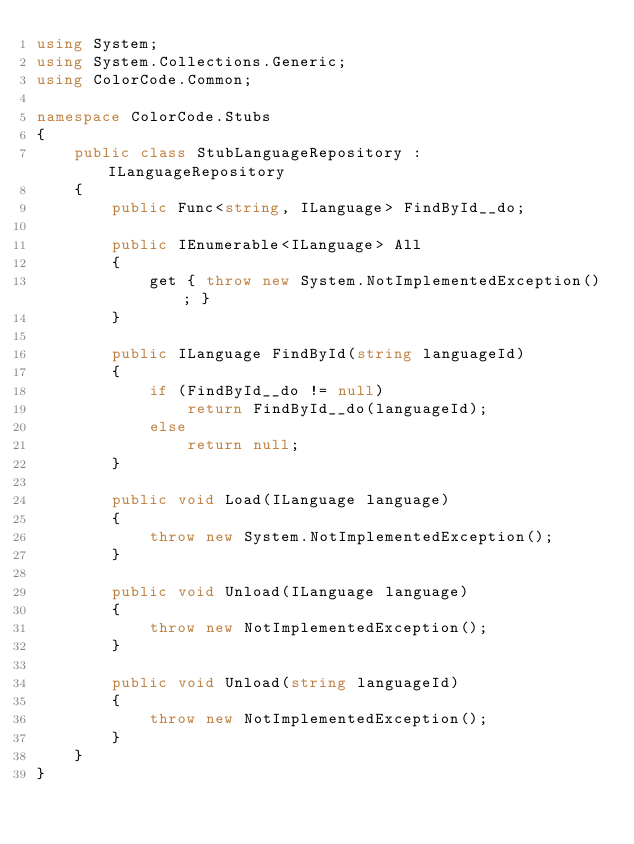<code> <loc_0><loc_0><loc_500><loc_500><_C#_>using System;
using System.Collections.Generic;
using ColorCode.Common;

namespace ColorCode.Stubs
{
    public class StubLanguageRepository : ILanguageRepository
    {
        public Func<string, ILanguage> FindById__do;

        public IEnumerable<ILanguage> All
        {
            get { throw new System.NotImplementedException(); }
        }

        public ILanguage FindById(string languageId)
        {
            if (FindById__do != null)
                return FindById__do(languageId);
            else
                return null;
        }

        public void Load(ILanguage language)
        {
            throw new System.NotImplementedException();
        }

        public void Unload(ILanguage language)
        {
            throw new NotImplementedException();
        }

        public void Unload(string languageId)
        {
            throw new NotImplementedException();
        }
    }
}</code> 